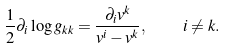<formula> <loc_0><loc_0><loc_500><loc_500>\frac { 1 } { 2 } \partial _ { i } \log { g _ { k k } } = \frac { \partial _ { i } v ^ { k } } { v ^ { i } - v ^ { k } } , \quad i \ne k .</formula> 